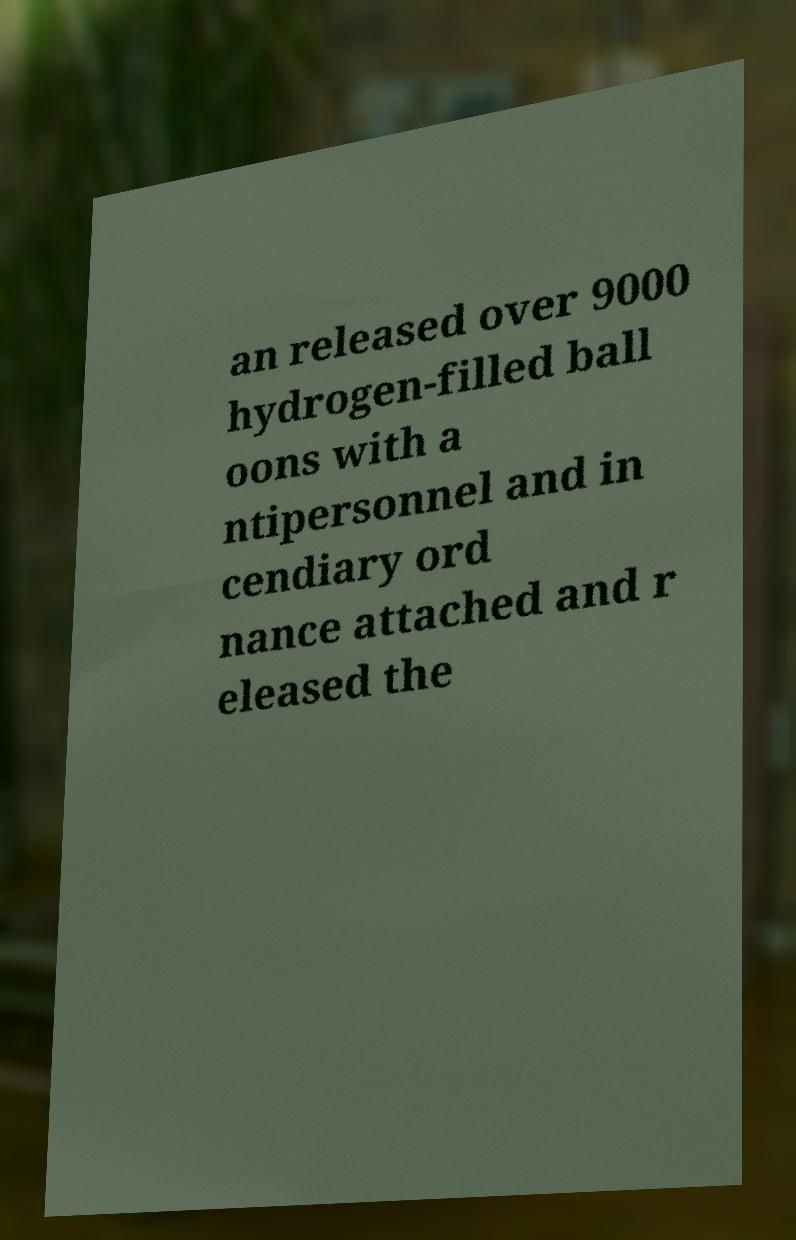What messages or text are displayed in this image? I need them in a readable, typed format. an released over 9000 hydrogen-filled ball oons with a ntipersonnel and in cendiary ord nance attached and r eleased the 